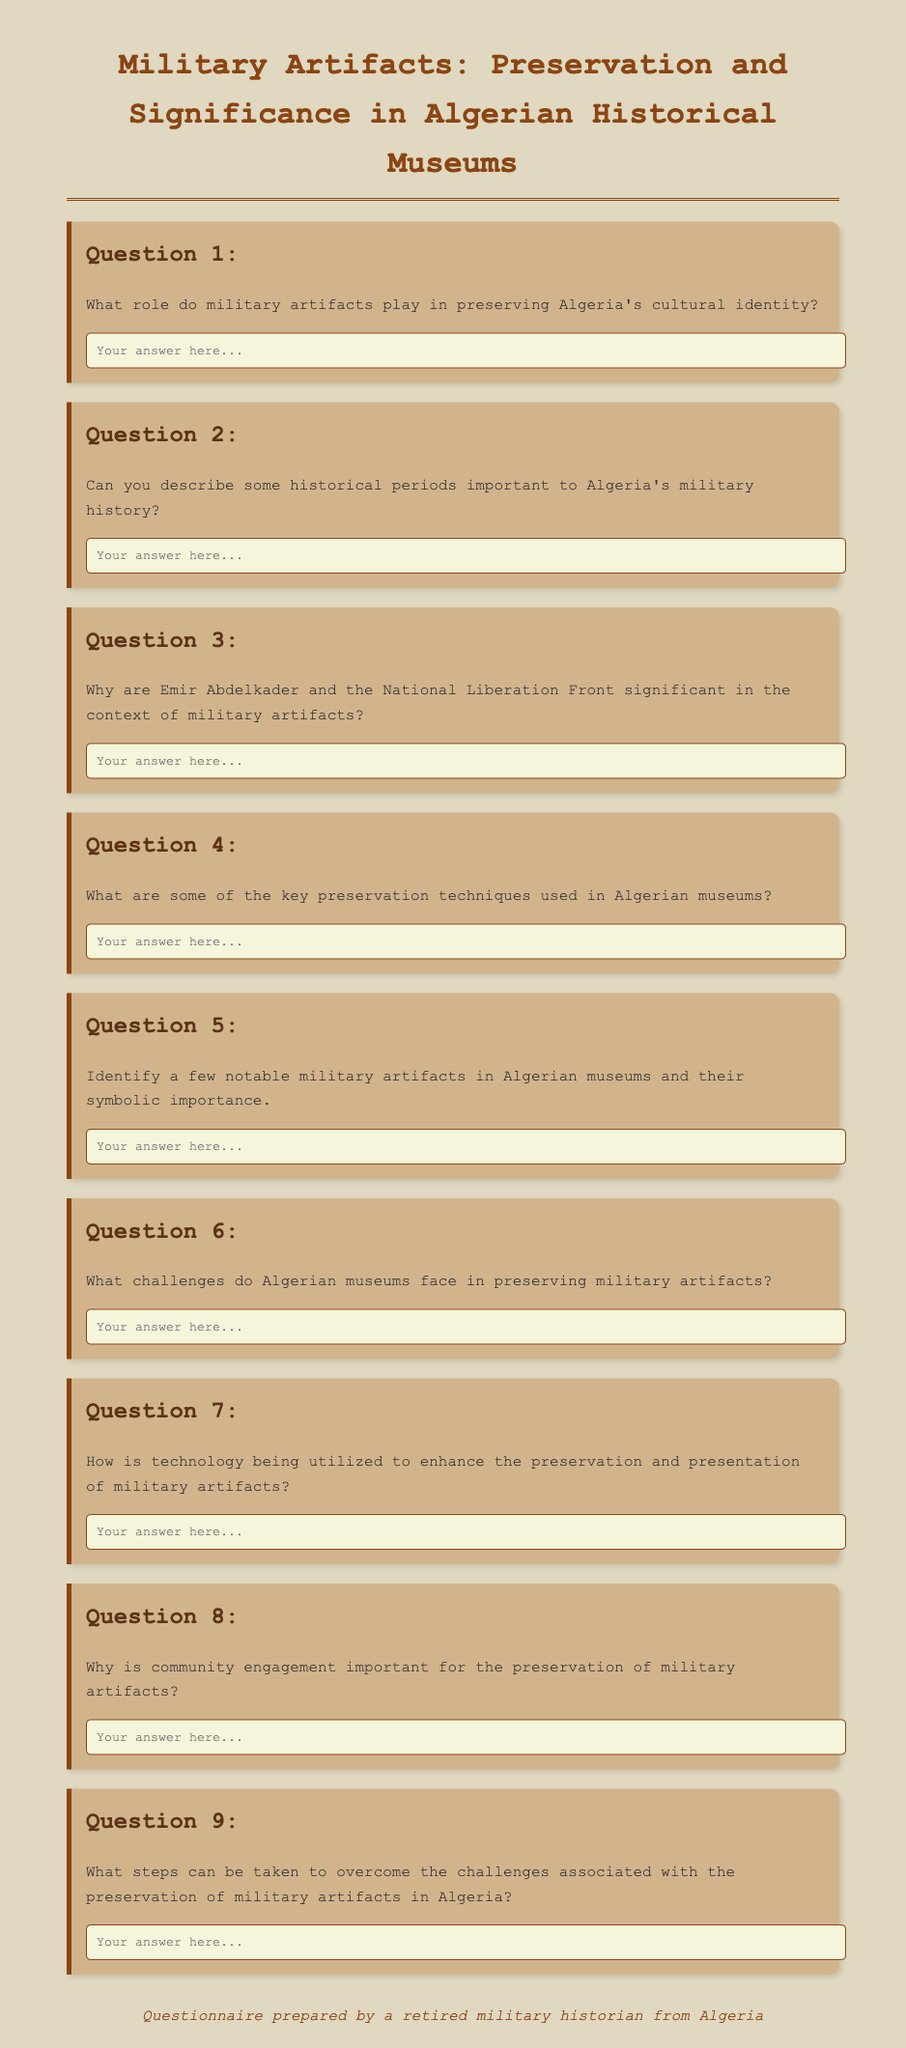What is the title of the document? The title is found in the head section of the HTML document.
Answer: Military Artifacts: Preservation and Significance in Algerian Historical Museums How many questions are there in the questionnaire? The count of questions is determined by the number of divs with class "question".
Answer: Nine What is the role of military artifacts according to Question 1? Question 1 asks about the role without providing an answer in the document itself.
Answer: Preserving Algeria's cultural identity Which significant figure is mentioned in Question 3? Question 3 specifically mentions Emir Abdelkader.
Answer: Emir Abdelkader What preservation techniques are referenced in Question 4? The document asks about preservation techniques without listing them.
Answer: Key preservation techniques What community aspect is highlighted in Question 8? Question 8 addresses the importance of community engagement for preservation.
Answer: Community engagement What challenges are discussed in Question 6? Question 6 indicates the challenges faced by museums without specifying them in the document.
Answer: Challenges in preserving military artifacts How is technology mentioned in relation to military artifacts? Question 7 inquires about technology's utilization but does not provide specifics in the document.
Answer: Enhance preservation and presentation What is the footer's message in the document? The footer provides information about who prepared the questionnaire.
Answer: Questionnaire prepared by a retired military historian from Algeria 